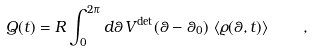<formula> <loc_0><loc_0><loc_500><loc_500>Q ( t ) = R \int _ { 0 } ^ { 2 \pi } d \theta \, V ^ { \text {det} } ( \theta - \theta _ { 0 } ) \, \left < \varrho ( \theta , t ) \right > \quad ,</formula> 